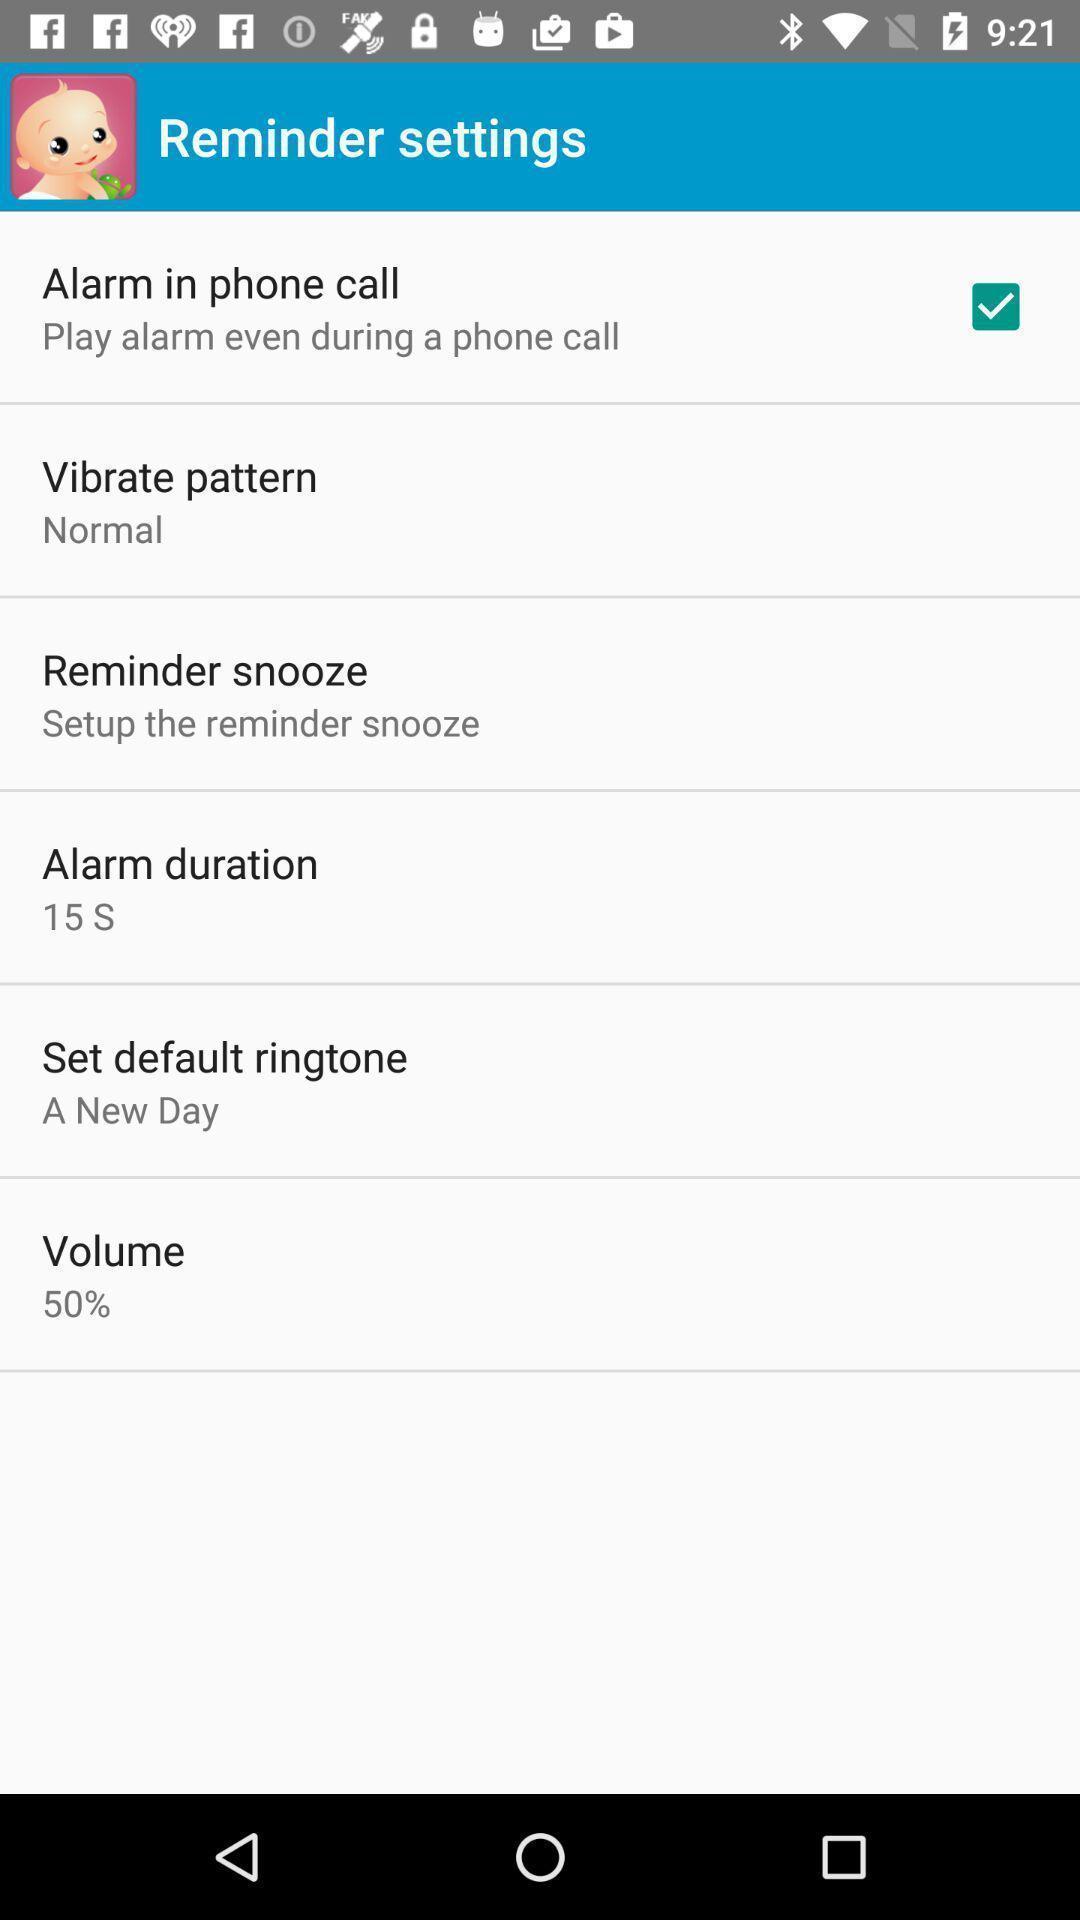Summarize the main components in this picture. Settings page with few options in an baby health application. 